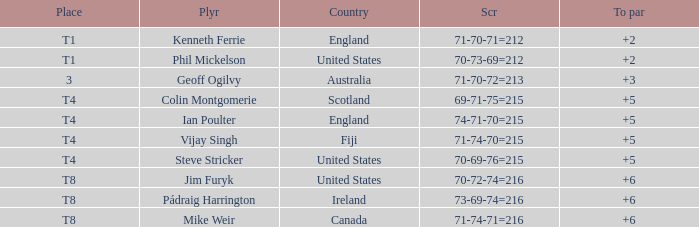What score to par did Mike Weir have? 6.0. 